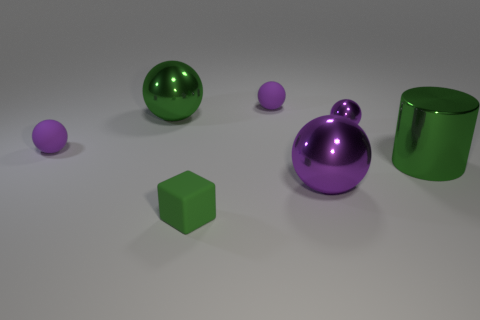Subtract all purple spheres. How many were subtracted if there are2purple spheres left? 2 Subtract all yellow blocks. How many purple balls are left? 4 Subtract all red spheres. Subtract all yellow cylinders. How many spheres are left? 5 Add 3 small cyan rubber cylinders. How many objects exist? 10 Subtract all blocks. How many objects are left? 6 Subtract 0 brown cylinders. How many objects are left? 7 Subtract all purple metal spheres. Subtract all tiny metal spheres. How many objects are left? 4 Add 7 big green metallic objects. How many big green metallic objects are left? 9 Add 3 green shiny cylinders. How many green shiny cylinders exist? 4 